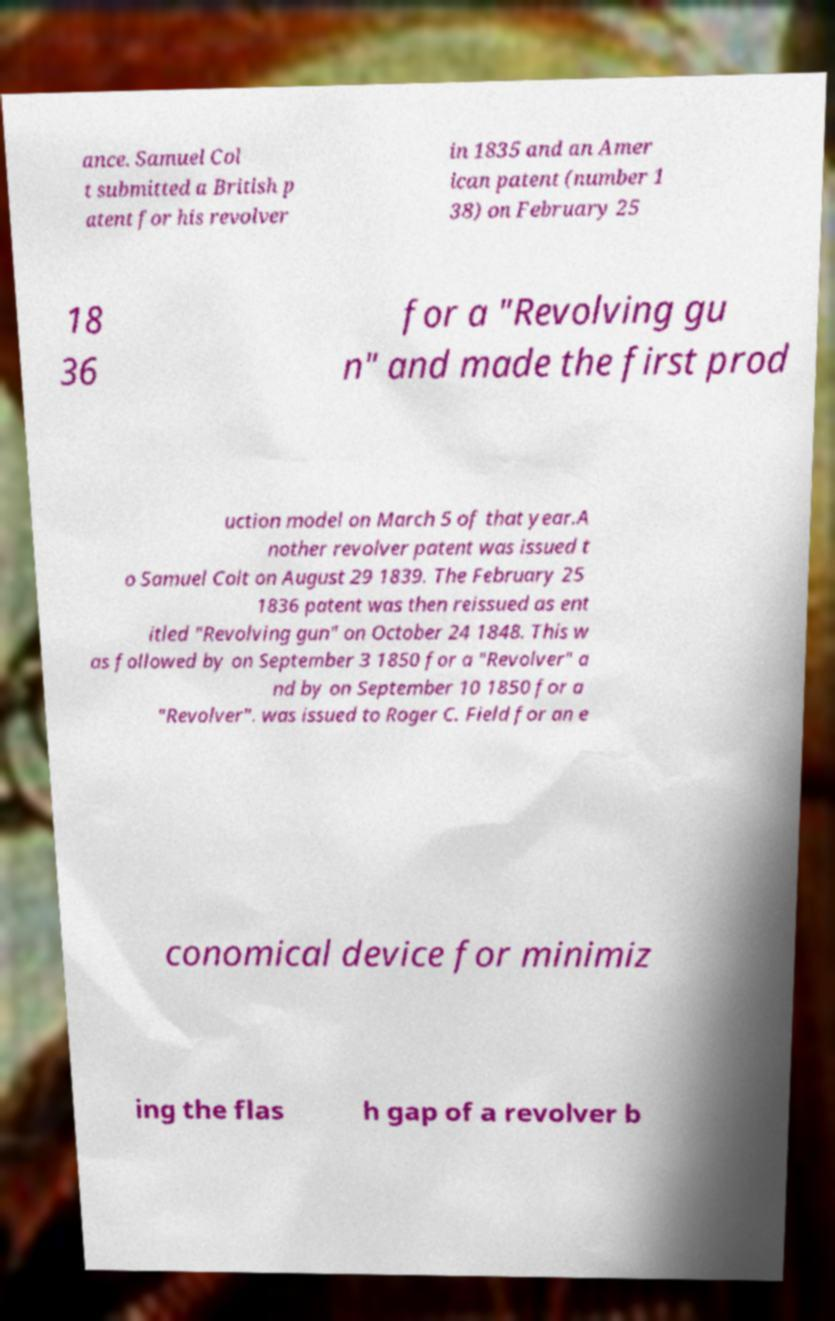Please read and relay the text visible in this image. What does it say? ance. Samuel Col t submitted a British p atent for his revolver in 1835 and an Amer ican patent (number 1 38) on February 25 18 36 for a "Revolving gu n" and made the first prod uction model on March 5 of that year.A nother revolver patent was issued t o Samuel Colt on August 29 1839. The February 25 1836 patent was then reissued as ent itled "Revolving gun" on October 24 1848. This w as followed by on September 3 1850 for a "Revolver" a nd by on September 10 1850 for a "Revolver". was issued to Roger C. Field for an e conomical device for minimiz ing the flas h gap of a revolver b 